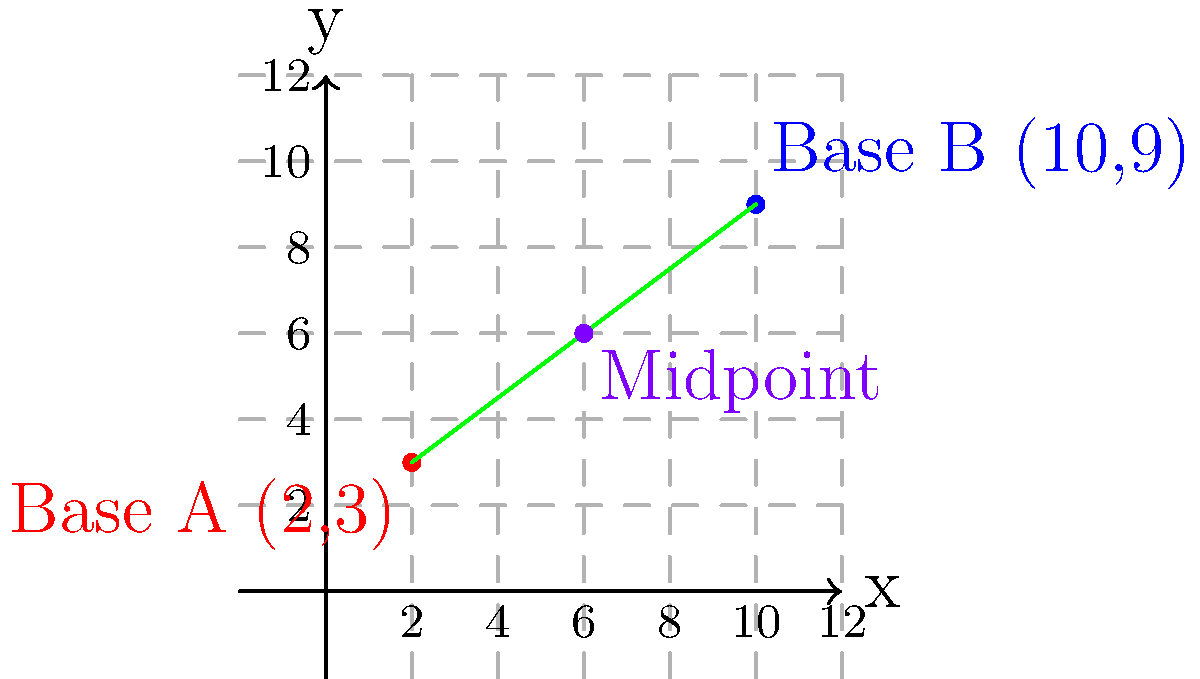As a logistics officer, you're tasked with establishing a supply depot at the midpoint of a route between two military bases. Base A is located at coordinates (2,3) and Base B is at (10,9). Calculate the coordinates of the midpoint where the supply depot should be positioned. To find the midpoint between two points, we use the midpoint formula:

Midpoint = $(\frac{x_1 + x_2}{2}, \frac{y_1 + y_2}{2})$

Where $(x_1, y_1)$ are the coordinates of the first point and $(x_2, y_2)$ are the coordinates of the second point.

Given:
Base A: $(x_1, y_1) = (2, 3)$
Base B: $(x_2, y_2) = (10, 9)$

Step 1: Calculate the x-coordinate of the midpoint:
$x_{midpoint} = \frac{x_1 + x_2}{2} = \frac{2 + 10}{2} = \frac{12}{2} = 6$

Step 2: Calculate the y-coordinate of the midpoint:
$y_{midpoint} = \frac{y_1 + y_2}{2} = \frac{3 + 9}{2} = \frac{12}{2} = 6$

Step 3: Combine the x and y coordinates to get the midpoint:
Midpoint = $(6, 6)$

Therefore, the supply depot should be positioned at coordinates (6,6).
Answer: (6,6) 